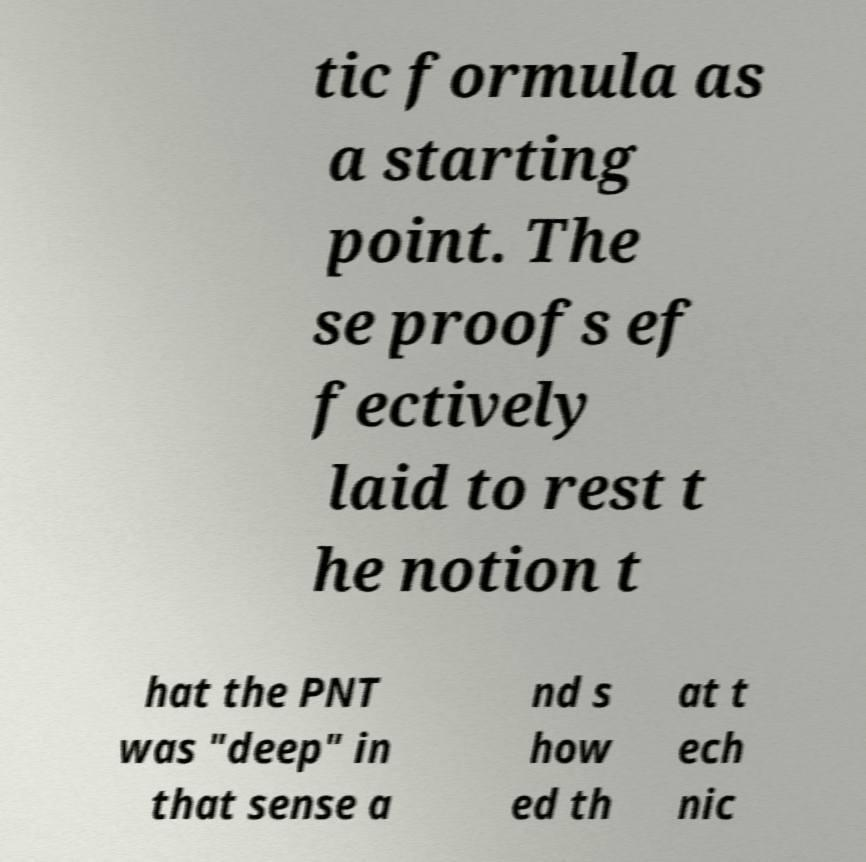There's text embedded in this image that I need extracted. Can you transcribe it verbatim? tic formula as a starting point. The se proofs ef fectively laid to rest t he notion t hat the PNT was "deep" in that sense a nd s how ed th at t ech nic 